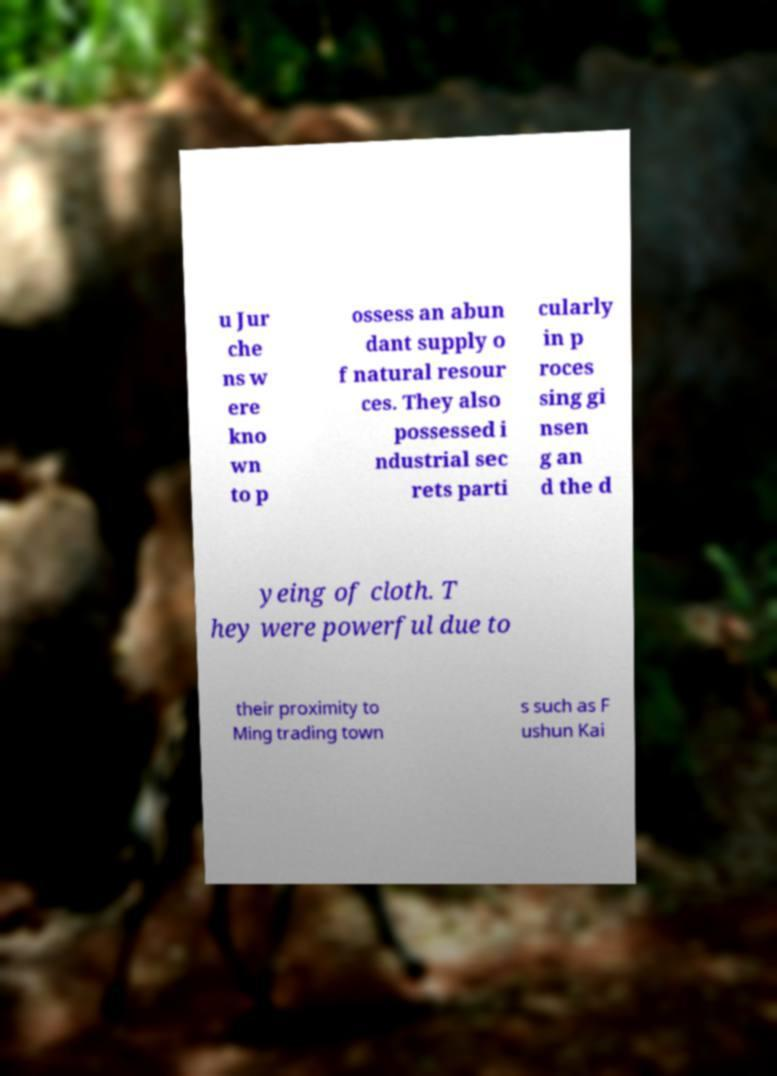Can you read and provide the text displayed in the image?This photo seems to have some interesting text. Can you extract and type it out for me? u Jur che ns w ere kno wn to p ossess an abun dant supply o f natural resour ces. They also possessed i ndustrial sec rets parti cularly in p roces sing gi nsen g an d the d yeing of cloth. T hey were powerful due to their proximity to Ming trading town s such as F ushun Kai 